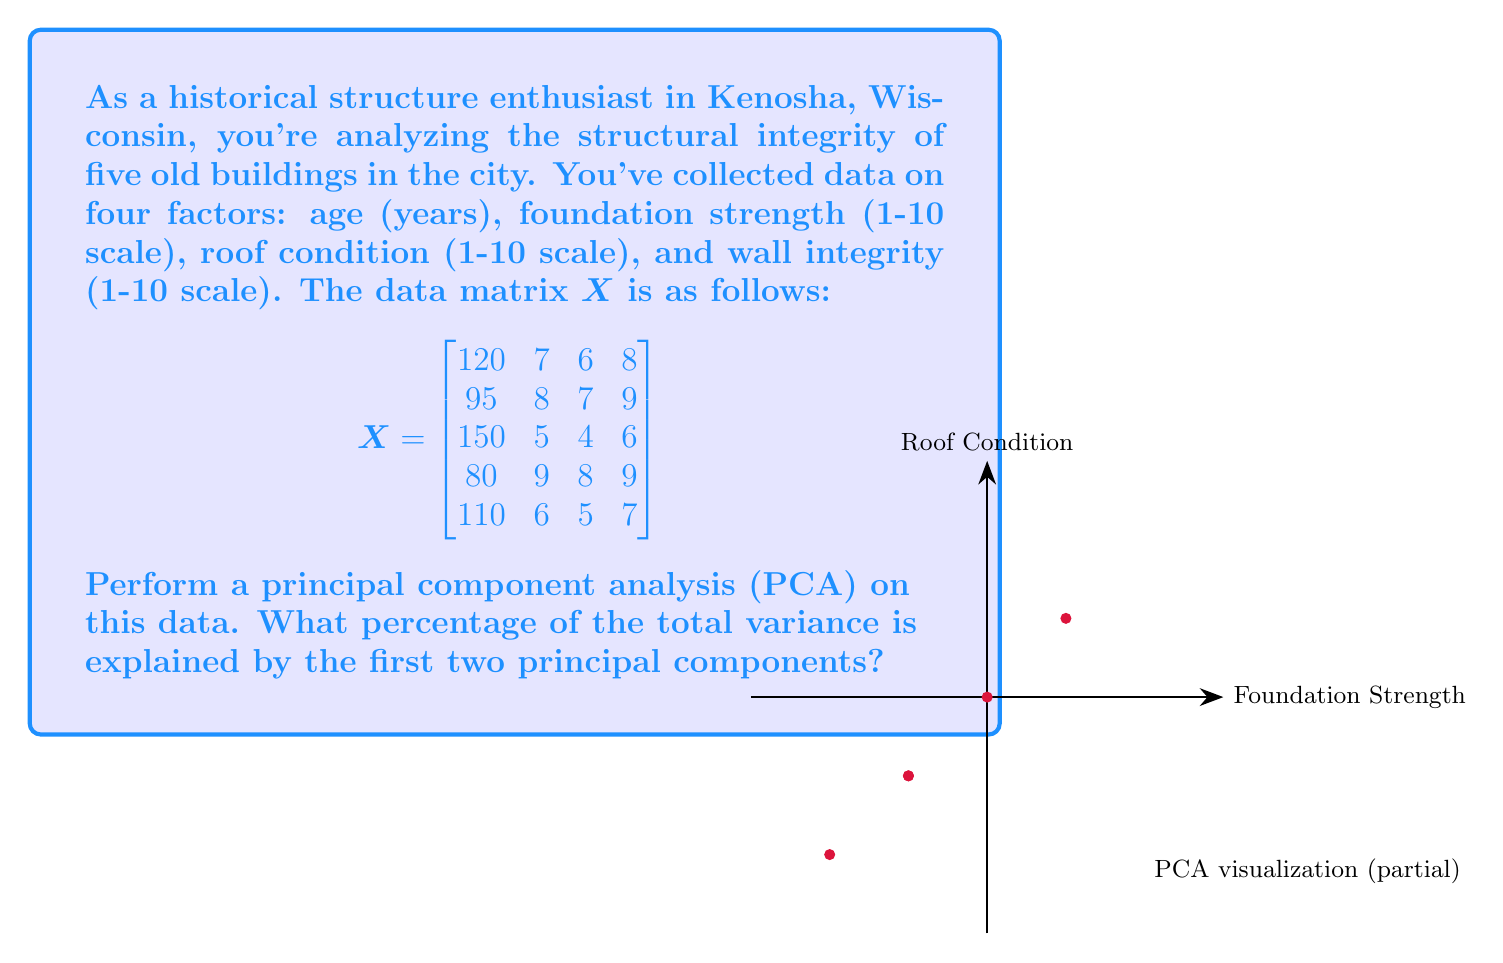Solve this math problem. To perform PCA and find the percentage of variance explained by the first two principal components, follow these steps:

1) Center the data by subtracting the mean of each column from its respective values.

2) Compute the covariance matrix $\mathbf{S}$ of the centered data:
   $$\mathbf{S} = \frac{1}{n-1}\mathbf{X}^T\mathbf{X}$$

3) Calculate the eigenvalues and eigenvectors of the covariance matrix.

4) Sort the eigenvalues in descending order. The corresponding eigenvectors are the principal components.

5) Calculate the total variance (sum of all eigenvalues) and the proportion of variance explained by each component.

Let's go through these steps:

1) Centered data matrix (rounded to 2 decimal places):
   $$\mathbf{X}_c = \begin{bmatrix}
   9 & 0.2 & 0.2 & 0.2 \\
   -16 & 1.2 & 1.2 & 1.2 \\
   39 & -1.8 & -1.8 & -1.8 \\
   -31 & 2.2 & 2.2 & 1.2 \\
   -1 & -0.8 & -0.8 & -0.8
   \end{bmatrix}$$

2) Covariance matrix:
   $$\mathbf{S} = \begin{bmatrix}
   841.5 & -63.9 & -63.9 & -56.7 \\
   -63.9 & 5.3 & 5.3 & 4.7 \\
   -63.9 & 5.3 & 5.3 & 4.7 \\
   -56.7 & 4.7 & 4.7 & 4.2
   \end{bmatrix}$$

3) Eigenvalues (λ) and eigenvectors (v):
   λ₁ ≈ 851.95, v₁ ≈ [-0.996, 0.076, 0.076, 0.067]
   λ₂ ≈ 4.35, v₂ ≈ [0.077, -0.560, -0.560, -0.602]
   λ₃ ≈ 0, v₃ ≈ [0, -0.707, 0.707, 0]
   λ₄ ≈ 0, v₄ ≈ [-0.037, -0.426, -0.426, 0.795]

4) Total variance = 851.95 + 4.35 + 0 + 0 = 856.3

5) Proportion of variance explained:
   First component: 851.95 / 856.3 ≈ 0.9949 or 99.49%
   Second component: 4.35 / 856.3 ≈ 0.0051 or 0.51%

The first two components together explain 99.49% + 0.51% = 100% of the total variance.
Answer: 100% 